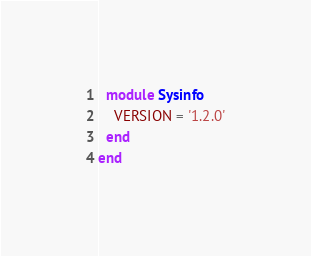<code> <loc_0><loc_0><loc_500><loc_500><_Ruby_>  module Sysinfo
    VERSION = '1.2.0'
  end
end
</code> 